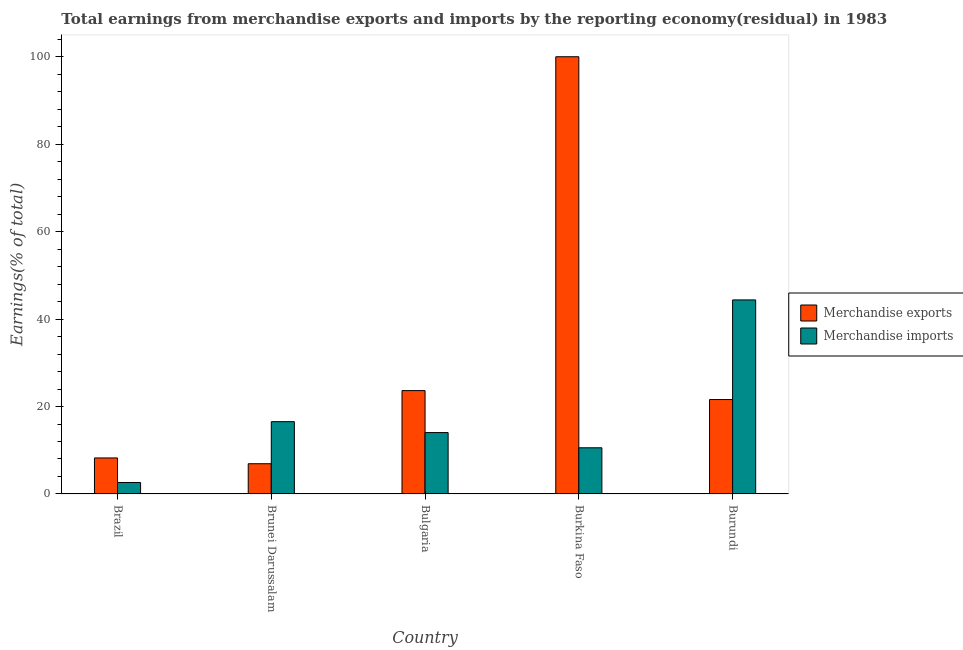How many groups of bars are there?
Provide a short and direct response. 5. Are the number of bars on each tick of the X-axis equal?
Your answer should be very brief. Yes. How many bars are there on the 5th tick from the left?
Ensure brevity in your answer.  2. How many bars are there on the 2nd tick from the right?
Your answer should be compact. 2. What is the earnings from merchandise exports in Burundi?
Keep it short and to the point. 21.6. Across all countries, what is the minimum earnings from merchandise exports?
Offer a terse response. 6.92. In which country was the earnings from merchandise imports maximum?
Your answer should be very brief. Burundi. What is the total earnings from merchandise imports in the graph?
Make the answer very short. 88.15. What is the difference between the earnings from merchandise imports in Brazil and that in Burundi?
Your answer should be compact. -41.76. What is the difference between the earnings from merchandise imports in Bulgaria and the earnings from merchandise exports in Brazil?
Your answer should be very brief. 5.8. What is the average earnings from merchandise imports per country?
Your response must be concise. 17.63. What is the difference between the earnings from merchandise imports and earnings from merchandise exports in Brunei Darussalam?
Offer a terse response. 9.62. In how many countries, is the earnings from merchandise imports greater than 68 %?
Your response must be concise. 0. What is the ratio of the earnings from merchandise imports in Brunei Darussalam to that in Burundi?
Ensure brevity in your answer.  0.37. Is the difference between the earnings from merchandise exports in Brunei Darussalam and Bulgaria greater than the difference between the earnings from merchandise imports in Brunei Darussalam and Bulgaria?
Offer a very short reply. No. What is the difference between the highest and the second highest earnings from merchandise imports?
Give a very brief answer. 27.84. What is the difference between the highest and the lowest earnings from merchandise imports?
Offer a terse response. 41.76. In how many countries, is the earnings from merchandise exports greater than the average earnings from merchandise exports taken over all countries?
Provide a short and direct response. 1. Is the sum of the earnings from merchandise imports in Brazil and Burkina Faso greater than the maximum earnings from merchandise exports across all countries?
Keep it short and to the point. No. How many bars are there?
Keep it short and to the point. 10. Are all the bars in the graph horizontal?
Offer a very short reply. No. Does the graph contain grids?
Keep it short and to the point. No. How many legend labels are there?
Your response must be concise. 2. How are the legend labels stacked?
Your response must be concise. Vertical. What is the title of the graph?
Give a very brief answer. Total earnings from merchandise exports and imports by the reporting economy(residual) in 1983. What is the label or title of the X-axis?
Offer a terse response. Country. What is the label or title of the Y-axis?
Your answer should be compact. Earnings(% of total). What is the Earnings(% of total) of Merchandise exports in Brazil?
Your response must be concise. 8.24. What is the Earnings(% of total) of Merchandise imports in Brazil?
Keep it short and to the point. 2.63. What is the Earnings(% of total) of Merchandise exports in Brunei Darussalam?
Make the answer very short. 6.92. What is the Earnings(% of total) of Merchandise imports in Brunei Darussalam?
Your answer should be compact. 16.54. What is the Earnings(% of total) in Merchandise exports in Bulgaria?
Keep it short and to the point. 23.64. What is the Earnings(% of total) of Merchandise imports in Bulgaria?
Make the answer very short. 14.04. What is the Earnings(% of total) in Merchandise imports in Burkina Faso?
Your answer should be very brief. 10.56. What is the Earnings(% of total) in Merchandise exports in Burundi?
Ensure brevity in your answer.  21.6. What is the Earnings(% of total) in Merchandise imports in Burundi?
Offer a very short reply. 44.38. Across all countries, what is the maximum Earnings(% of total) of Merchandise exports?
Your answer should be very brief. 100. Across all countries, what is the maximum Earnings(% of total) in Merchandise imports?
Make the answer very short. 44.38. Across all countries, what is the minimum Earnings(% of total) of Merchandise exports?
Your answer should be compact. 6.92. Across all countries, what is the minimum Earnings(% of total) in Merchandise imports?
Keep it short and to the point. 2.63. What is the total Earnings(% of total) of Merchandise exports in the graph?
Keep it short and to the point. 160.4. What is the total Earnings(% of total) in Merchandise imports in the graph?
Your answer should be very brief. 88.15. What is the difference between the Earnings(% of total) in Merchandise exports in Brazil and that in Brunei Darussalam?
Offer a very short reply. 1.32. What is the difference between the Earnings(% of total) of Merchandise imports in Brazil and that in Brunei Darussalam?
Ensure brevity in your answer.  -13.91. What is the difference between the Earnings(% of total) of Merchandise exports in Brazil and that in Bulgaria?
Your answer should be very brief. -15.4. What is the difference between the Earnings(% of total) of Merchandise imports in Brazil and that in Bulgaria?
Keep it short and to the point. -11.41. What is the difference between the Earnings(% of total) in Merchandise exports in Brazil and that in Burkina Faso?
Ensure brevity in your answer.  -91.76. What is the difference between the Earnings(% of total) of Merchandise imports in Brazil and that in Burkina Faso?
Ensure brevity in your answer.  -7.94. What is the difference between the Earnings(% of total) of Merchandise exports in Brazil and that in Burundi?
Your answer should be compact. -13.36. What is the difference between the Earnings(% of total) of Merchandise imports in Brazil and that in Burundi?
Make the answer very short. -41.76. What is the difference between the Earnings(% of total) in Merchandise exports in Brunei Darussalam and that in Bulgaria?
Offer a terse response. -16.73. What is the difference between the Earnings(% of total) of Merchandise imports in Brunei Darussalam and that in Bulgaria?
Offer a terse response. 2.5. What is the difference between the Earnings(% of total) in Merchandise exports in Brunei Darussalam and that in Burkina Faso?
Ensure brevity in your answer.  -93.08. What is the difference between the Earnings(% of total) in Merchandise imports in Brunei Darussalam and that in Burkina Faso?
Your response must be concise. 5.98. What is the difference between the Earnings(% of total) of Merchandise exports in Brunei Darussalam and that in Burundi?
Offer a terse response. -14.68. What is the difference between the Earnings(% of total) in Merchandise imports in Brunei Darussalam and that in Burundi?
Make the answer very short. -27.84. What is the difference between the Earnings(% of total) of Merchandise exports in Bulgaria and that in Burkina Faso?
Make the answer very short. -76.36. What is the difference between the Earnings(% of total) of Merchandise imports in Bulgaria and that in Burkina Faso?
Your answer should be very brief. 3.48. What is the difference between the Earnings(% of total) of Merchandise exports in Bulgaria and that in Burundi?
Your answer should be very brief. 2.04. What is the difference between the Earnings(% of total) in Merchandise imports in Bulgaria and that in Burundi?
Ensure brevity in your answer.  -30.34. What is the difference between the Earnings(% of total) in Merchandise exports in Burkina Faso and that in Burundi?
Your answer should be very brief. 78.4. What is the difference between the Earnings(% of total) in Merchandise imports in Burkina Faso and that in Burundi?
Provide a short and direct response. -33.82. What is the difference between the Earnings(% of total) of Merchandise exports in Brazil and the Earnings(% of total) of Merchandise imports in Brunei Darussalam?
Your answer should be compact. -8.3. What is the difference between the Earnings(% of total) in Merchandise exports in Brazil and the Earnings(% of total) in Merchandise imports in Bulgaria?
Your answer should be very brief. -5.8. What is the difference between the Earnings(% of total) in Merchandise exports in Brazil and the Earnings(% of total) in Merchandise imports in Burkina Faso?
Provide a succinct answer. -2.32. What is the difference between the Earnings(% of total) in Merchandise exports in Brazil and the Earnings(% of total) in Merchandise imports in Burundi?
Keep it short and to the point. -36.14. What is the difference between the Earnings(% of total) of Merchandise exports in Brunei Darussalam and the Earnings(% of total) of Merchandise imports in Bulgaria?
Provide a succinct answer. -7.12. What is the difference between the Earnings(% of total) of Merchandise exports in Brunei Darussalam and the Earnings(% of total) of Merchandise imports in Burkina Faso?
Give a very brief answer. -3.65. What is the difference between the Earnings(% of total) of Merchandise exports in Brunei Darussalam and the Earnings(% of total) of Merchandise imports in Burundi?
Your answer should be compact. -37.47. What is the difference between the Earnings(% of total) in Merchandise exports in Bulgaria and the Earnings(% of total) in Merchandise imports in Burkina Faso?
Make the answer very short. 13.08. What is the difference between the Earnings(% of total) of Merchandise exports in Bulgaria and the Earnings(% of total) of Merchandise imports in Burundi?
Offer a very short reply. -20.74. What is the difference between the Earnings(% of total) in Merchandise exports in Burkina Faso and the Earnings(% of total) in Merchandise imports in Burundi?
Keep it short and to the point. 55.62. What is the average Earnings(% of total) in Merchandise exports per country?
Offer a terse response. 32.08. What is the average Earnings(% of total) in Merchandise imports per country?
Provide a short and direct response. 17.63. What is the difference between the Earnings(% of total) in Merchandise exports and Earnings(% of total) in Merchandise imports in Brazil?
Provide a succinct answer. 5.61. What is the difference between the Earnings(% of total) in Merchandise exports and Earnings(% of total) in Merchandise imports in Brunei Darussalam?
Ensure brevity in your answer.  -9.62. What is the difference between the Earnings(% of total) in Merchandise exports and Earnings(% of total) in Merchandise imports in Bulgaria?
Offer a terse response. 9.6. What is the difference between the Earnings(% of total) of Merchandise exports and Earnings(% of total) of Merchandise imports in Burkina Faso?
Your response must be concise. 89.44. What is the difference between the Earnings(% of total) of Merchandise exports and Earnings(% of total) of Merchandise imports in Burundi?
Provide a short and direct response. -22.79. What is the ratio of the Earnings(% of total) of Merchandise exports in Brazil to that in Brunei Darussalam?
Provide a short and direct response. 1.19. What is the ratio of the Earnings(% of total) of Merchandise imports in Brazil to that in Brunei Darussalam?
Keep it short and to the point. 0.16. What is the ratio of the Earnings(% of total) in Merchandise exports in Brazil to that in Bulgaria?
Your answer should be compact. 0.35. What is the ratio of the Earnings(% of total) of Merchandise imports in Brazil to that in Bulgaria?
Provide a short and direct response. 0.19. What is the ratio of the Earnings(% of total) in Merchandise exports in Brazil to that in Burkina Faso?
Your answer should be compact. 0.08. What is the ratio of the Earnings(% of total) of Merchandise imports in Brazil to that in Burkina Faso?
Offer a very short reply. 0.25. What is the ratio of the Earnings(% of total) in Merchandise exports in Brazil to that in Burundi?
Your answer should be very brief. 0.38. What is the ratio of the Earnings(% of total) in Merchandise imports in Brazil to that in Burundi?
Offer a terse response. 0.06. What is the ratio of the Earnings(% of total) of Merchandise exports in Brunei Darussalam to that in Bulgaria?
Make the answer very short. 0.29. What is the ratio of the Earnings(% of total) in Merchandise imports in Brunei Darussalam to that in Bulgaria?
Your response must be concise. 1.18. What is the ratio of the Earnings(% of total) of Merchandise exports in Brunei Darussalam to that in Burkina Faso?
Your answer should be very brief. 0.07. What is the ratio of the Earnings(% of total) of Merchandise imports in Brunei Darussalam to that in Burkina Faso?
Your response must be concise. 1.57. What is the ratio of the Earnings(% of total) of Merchandise exports in Brunei Darussalam to that in Burundi?
Give a very brief answer. 0.32. What is the ratio of the Earnings(% of total) of Merchandise imports in Brunei Darussalam to that in Burundi?
Your answer should be compact. 0.37. What is the ratio of the Earnings(% of total) in Merchandise exports in Bulgaria to that in Burkina Faso?
Give a very brief answer. 0.24. What is the ratio of the Earnings(% of total) of Merchandise imports in Bulgaria to that in Burkina Faso?
Your response must be concise. 1.33. What is the ratio of the Earnings(% of total) in Merchandise exports in Bulgaria to that in Burundi?
Give a very brief answer. 1.09. What is the ratio of the Earnings(% of total) in Merchandise imports in Bulgaria to that in Burundi?
Ensure brevity in your answer.  0.32. What is the ratio of the Earnings(% of total) in Merchandise exports in Burkina Faso to that in Burundi?
Give a very brief answer. 4.63. What is the ratio of the Earnings(% of total) of Merchandise imports in Burkina Faso to that in Burundi?
Ensure brevity in your answer.  0.24. What is the difference between the highest and the second highest Earnings(% of total) of Merchandise exports?
Your answer should be very brief. 76.36. What is the difference between the highest and the second highest Earnings(% of total) of Merchandise imports?
Provide a succinct answer. 27.84. What is the difference between the highest and the lowest Earnings(% of total) in Merchandise exports?
Your answer should be compact. 93.08. What is the difference between the highest and the lowest Earnings(% of total) of Merchandise imports?
Make the answer very short. 41.76. 